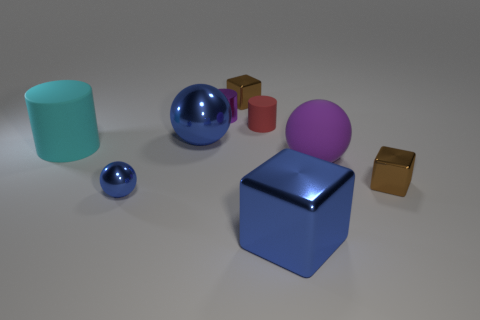Add 1 cyan metal spheres. How many objects exist? 10 Subtract all balls. How many objects are left? 6 Add 7 tiny cubes. How many tiny cubes exist? 9 Subtract 0 brown cylinders. How many objects are left? 9 Subtract all tiny purple metal cylinders. Subtract all purple objects. How many objects are left? 6 Add 1 balls. How many balls are left? 4 